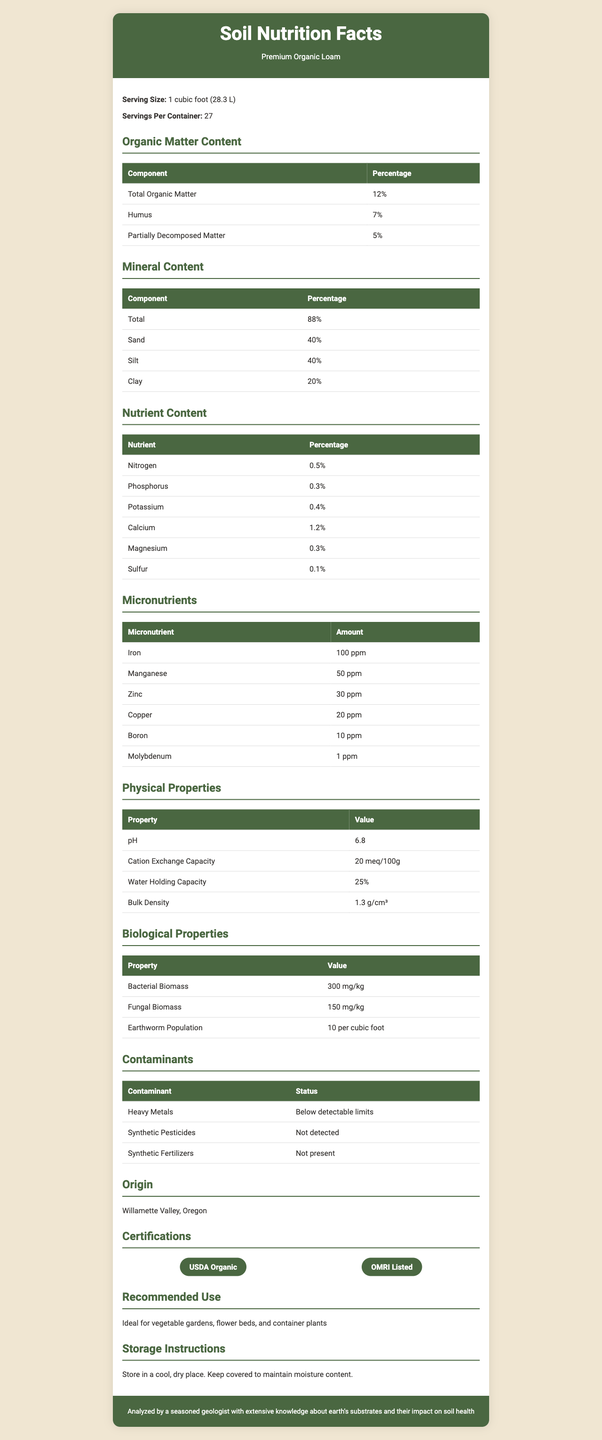what is the product name? The product name is clearly stated as "Premium Organic Loam" in the document header.
Answer: Premium Organic Loam what is the serving size? The serving size is mentioned in the first section of the document as "1 cubic foot (28.3 L)".
Answer: 1 cubic foot (28.3 L) how much total organic matter is present in the loam? The total organic matter is listed under the "Organic Matter Content" section as 12%.
Answer: 12% what is the percentage of humus in the loam? The percentage of humus is given as 7% in the "Organic Matter Content" section.
Answer: 7% how much nitrogen is in the loam? The nitrogen content is mentioned under the "Nutrient Content" section as 0.5%.
Answer: 0.5% what is the origin of the loam? The origin is specified in the "Origin" section as Willamette Valley, Oregon.
Answer: Willamette Valley, Oregon how should the loam be stored? The storage instructions provided are to store the loam in a cool, dry place and keep it covered to maintain moisture content.
Answer: Store in a cool, dry place. Keep covered to maintain moisture content. what does the term "bulk density" refer to in this context? "Bulk Density" is listed under "Physical Properties" with a value of 1.3 g/cm³.
Answer: 1.3 g/cm³ which certification(s) does the loam have? The certifications listed are USDA Organic and OMRI Listed.
Answer: USDA Organic, OMRI Listed which of the following minerals is present in the highest percentage? A. Sand B. Silt C. Clay Under the "Mineral Content" section, sand has the highest percentage at 40%, followed by silt at 40% and clay at 20%.
Answer: A. Sand based on the document, which micronutrient has the smallest concentration? A. Iron B. Molybdenum C. Boron D. Copper Molybdenum has the smallest concentration at 1 ppm, as seen in the "Micronutrients" section.
Answer: B. Molybdenum does the document indicate the presence of synthetic pesticides? Under the "Contaminants" section, it states that synthetic pesticides were not detected.
Answer: No summarize the main content of the document. The document is a comprehensive report on Premium Organic Loam, detailing its organic matter, mineral content, nutrients, micronutrients, physical and biological properties, origins, certifications, and recommended use and storage instructions.
Answer: The document provides detailed information about Premium Organic Loam, including its composition, nutrient and mineral content, physical and biological properties, certifications, origin, and storage instructions. what is the ratio of sand to clay in the loam? The ratio of sand to clay is 2:1, as sand is 40% and clay is 20%, both values found in the "Mineral Content" section.
Answer: 2:1 what is the water holding capacity of the loam? The water holding capacity is indicated as 25% under the "Physical Properties" section.
Answer: 25% which micronutrient content is not listed in the document? The document lists iron, manganese, zinc, copper, boron, and molybdenum, but does not mention which micronutrients are omitted. Thus, "Not enough information" is the correct answer.
Answer: Not enough information 